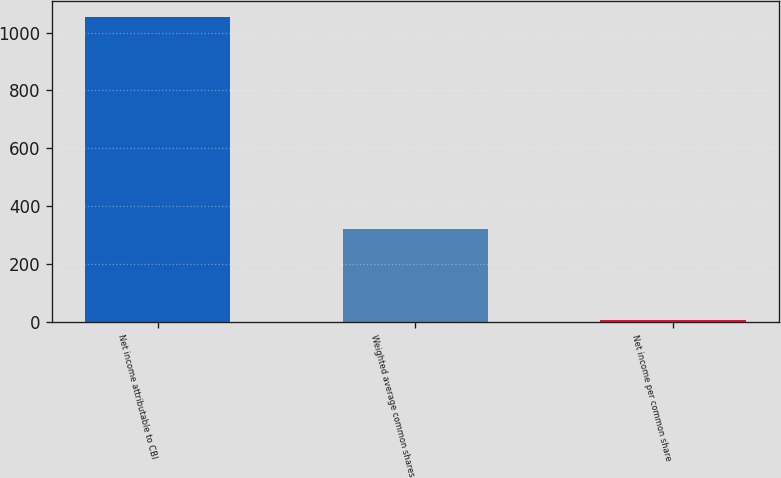<chart> <loc_0><loc_0><loc_500><loc_500><bar_chart><fcel>Net income attributable to CBI<fcel>Weighted average common shares<fcel>Net income per common share<nl><fcel>1054.9<fcel>320.09<fcel>5.18<nl></chart> 